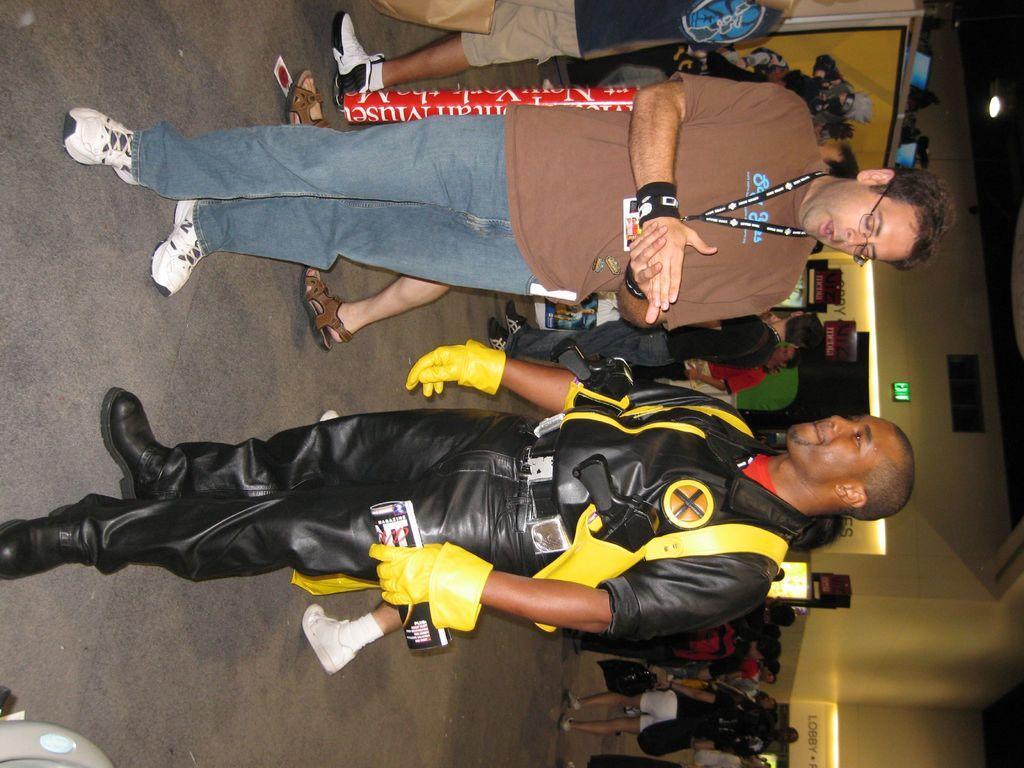Please provide a concise description of this image. In this image I can see two persons standing. The person standing in front wearing brown color shirt, blue color pant. The person at right wearing black color dress, background I can see few persons standing, wall in cream color. 